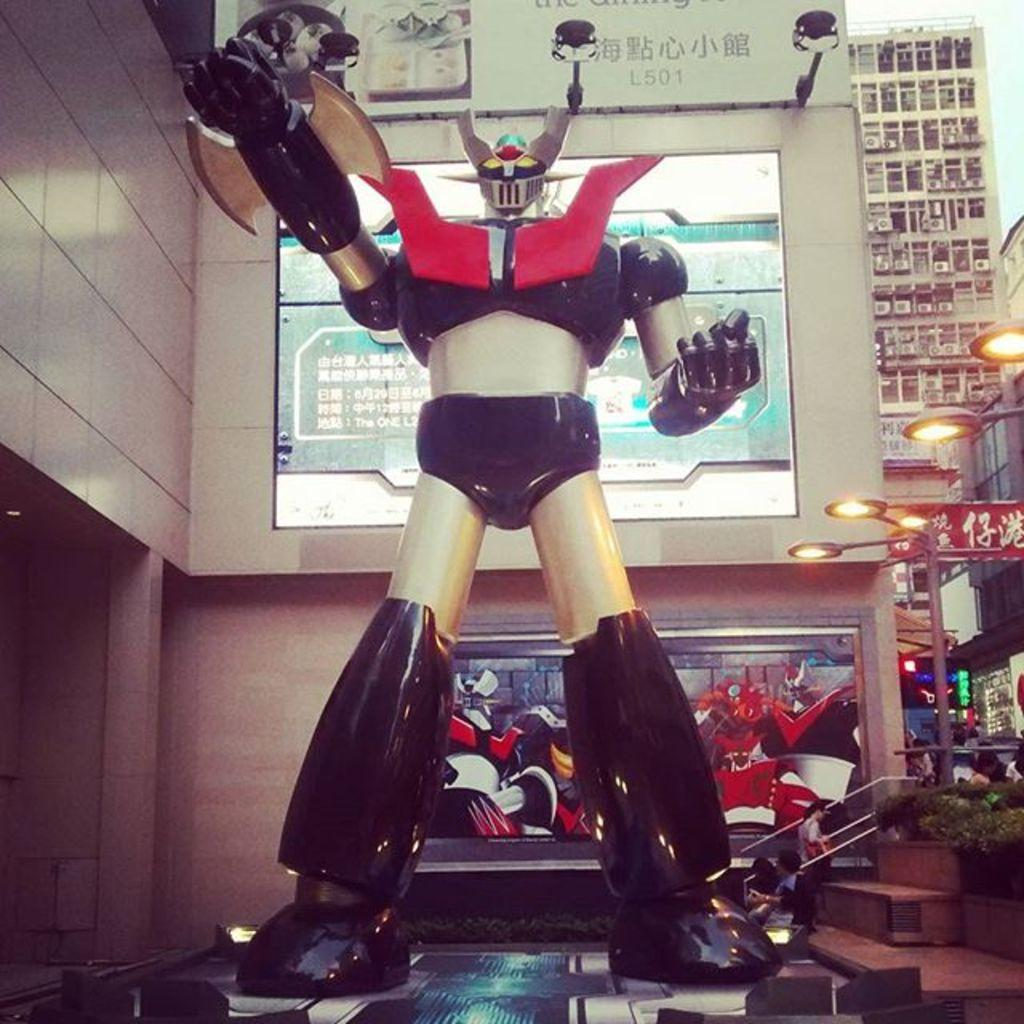What is the main subject of the image? There is a robot on a platform in the image. Are there any other living beings in the image? Yes, there are people in the image. What type of natural elements can be seen in the image? There are plants in the image. What kind of artificial lighting is present in the image? There are lights in the image. What else can be seen in the image besides the robot, people, and plants? There are objects in the image. What can be seen in the background of the image? There is a wall, screens, and buildings in the background of the image. What type of quartz is used to make the robot's body in the image? There is no mention of quartz or any specific materials used to make the robot's body in the image. How many umbrellas can be seen in the image? There are no umbrellas present in the image. 